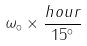<formula> <loc_0><loc_0><loc_500><loc_500>\omega _ { \circ } \times \frac { h o u r } { 1 5 ^ { \circ } }</formula> 